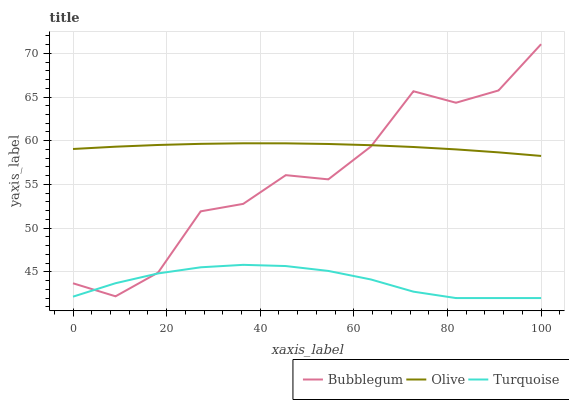Does Turquoise have the minimum area under the curve?
Answer yes or no. Yes. Does Olive have the maximum area under the curve?
Answer yes or no. Yes. Does Bubblegum have the minimum area under the curve?
Answer yes or no. No. Does Bubblegum have the maximum area under the curve?
Answer yes or no. No. Is Olive the smoothest?
Answer yes or no. Yes. Is Bubblegum the roughest?
Answer yes or no. Yes. Is Turquoise the smoothest?
Answer yes or no. No. Is Turquoise the roughest?
Answer yes or no. No. Does Turquoise have the lowest value?
Answer yes or no. Yes. Does Bubblegum have the lowest value?
Answer yes or no. No. Does Bubblegum have the highest value?
Answer yes or no. Yes. Does Turquoise have the highest value?
Answer yes or no. No. Is Turquoise less than Olive?
Answer yes or no. Yes. Is Olive greater than Turquoise?
Answer yes or no. Yes. Does Bubblegum intersect Turquoise?
Answer yes or no. Yes. Is Bubblegum less than Turquoise?
Answer yes or no. No. Is Bubblegum greater than Turquoise?
Answer yes or no. No. Does Turquoise intersect Olive?
Answer yes or no. No. 